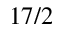<formula> <loc_0><loc_0><loc_500><loc_500>1 7 / 2</formula> 